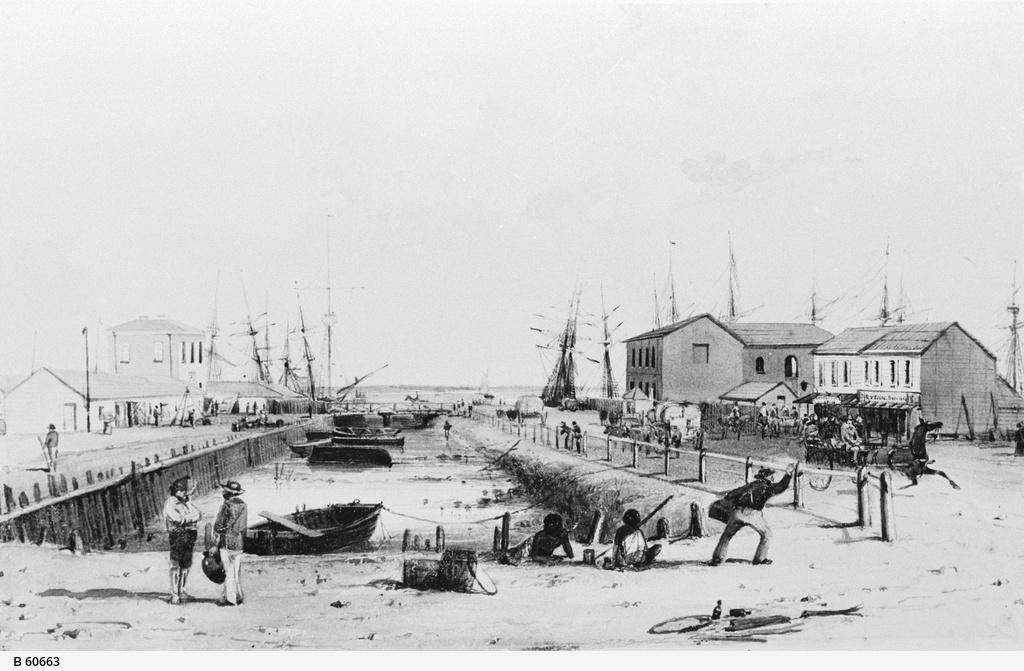Please provide a concise description of this image. In the image few people are standing and sitting. Behind them we can see water, boats and fencing. Behind the fencing few people are standing, walking and riding horses. Behind them we can see some buildings and poles. 